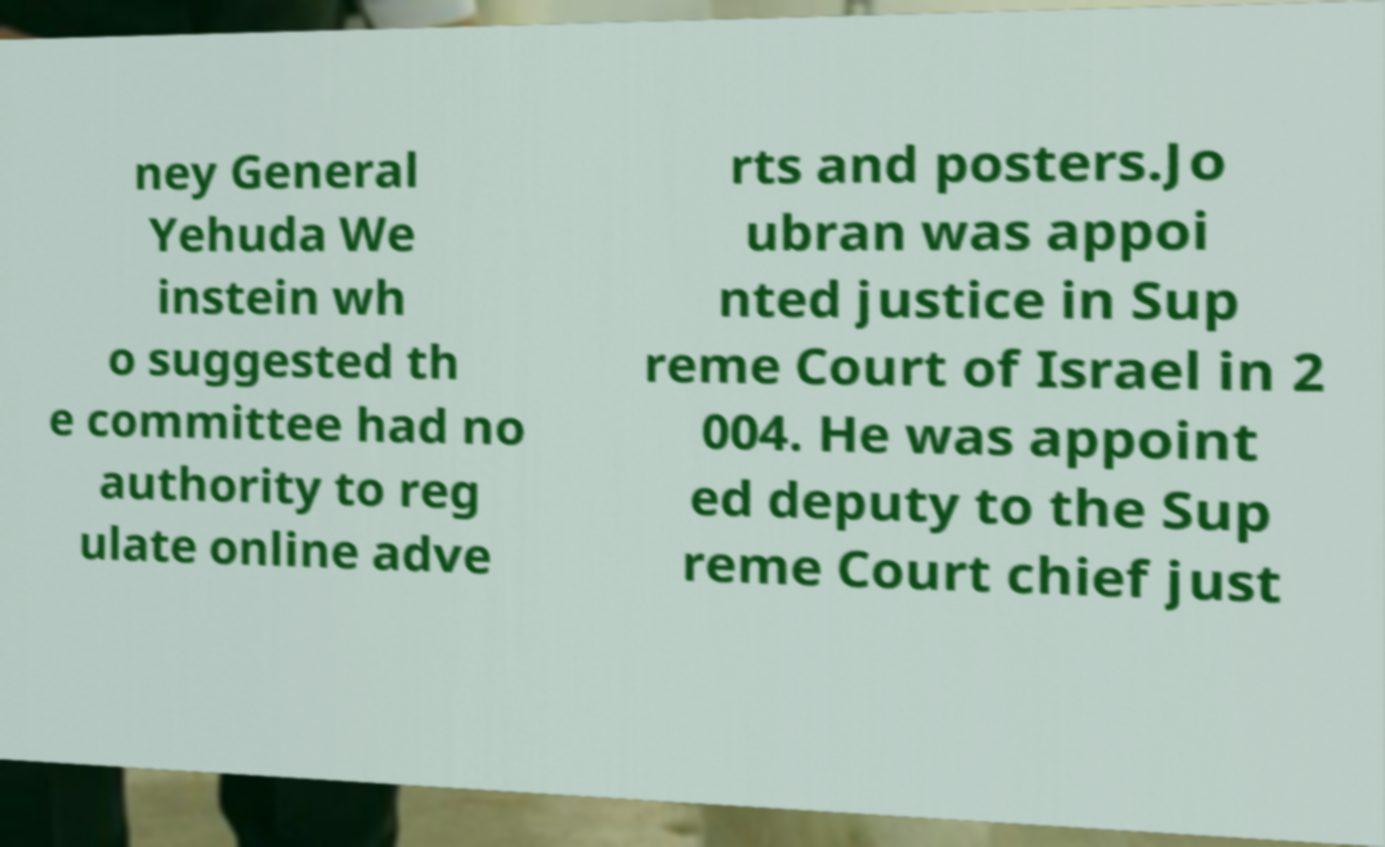Could you extract and type out the text from this image? ney General Yehuda We instein wh o suggested th e committee had no authority to reg ulate online adve rts and posters.Jo ubran was appoi nted justice in Sup reme Court of Israel in 2 004. He was appoint ed deputy to the Sup reme Court chief just 